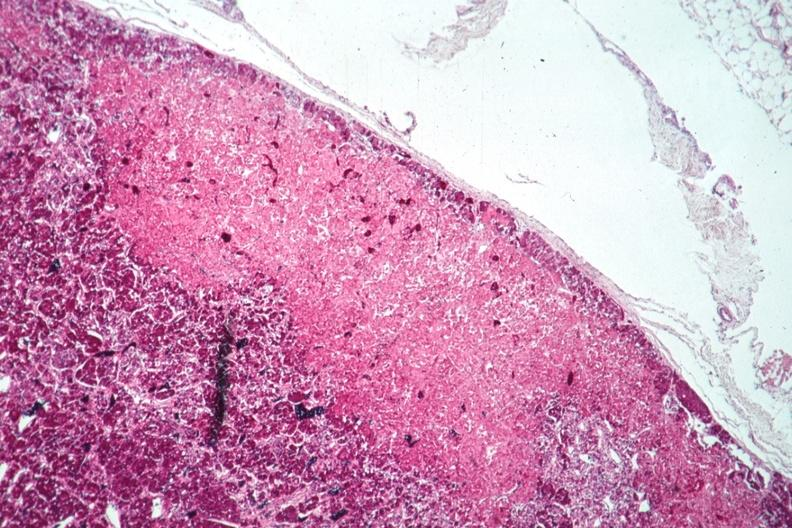does yo show well shown infarct?
Answer the question using a single word or phrase. No 